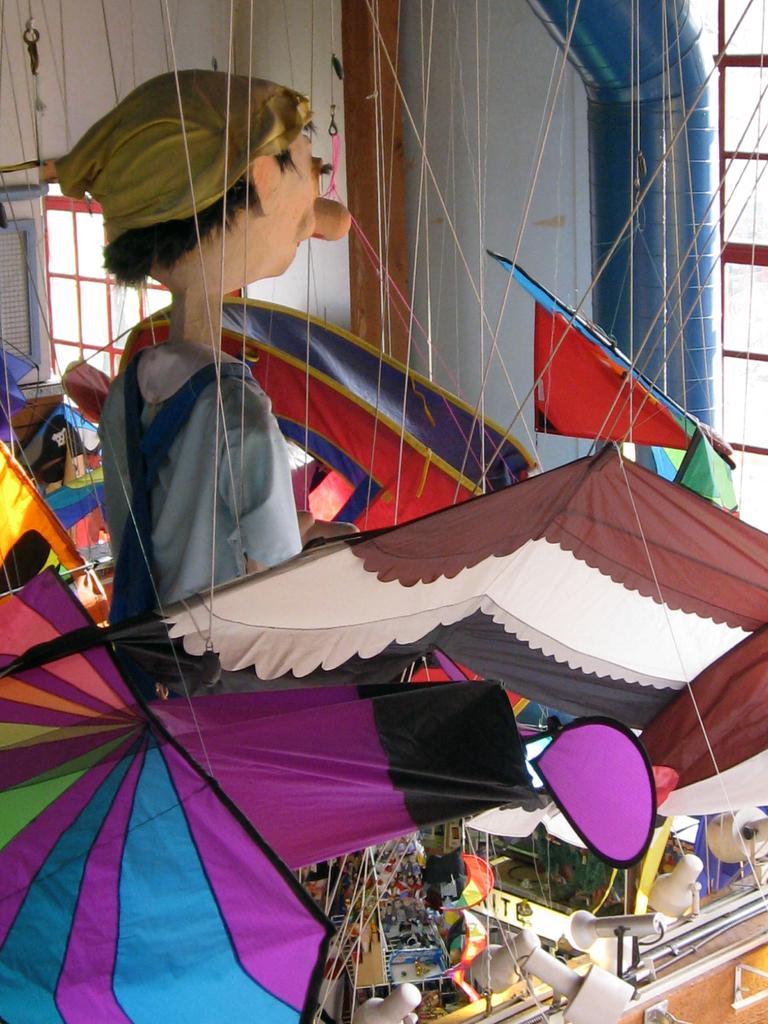How would you summarize this image in a sentence or two? In this image I can see the toy. To the side of the toy I can see many umbrellas. To the left I can see the window. To the right I can see the tent, boards, lights and many people. In the background I can see the sky. 